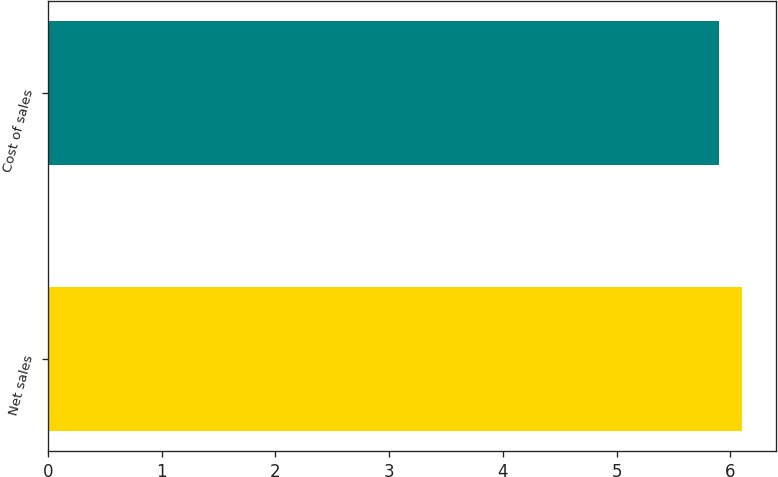Convert chart to OTSL. <chart><loc_0><loc_0><loc_500><loc_500><bar_chart><fcel>Net sales<fcel>Cost of sales<nl><fcel>6.1<fcel>5.9<nl></chart> 